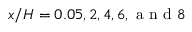<formula> <loc_0><loc_0><loc_500><loc_500>x / H = 0 . 0 5 , 2 , 4 , 6 , a n d 8</formula> 